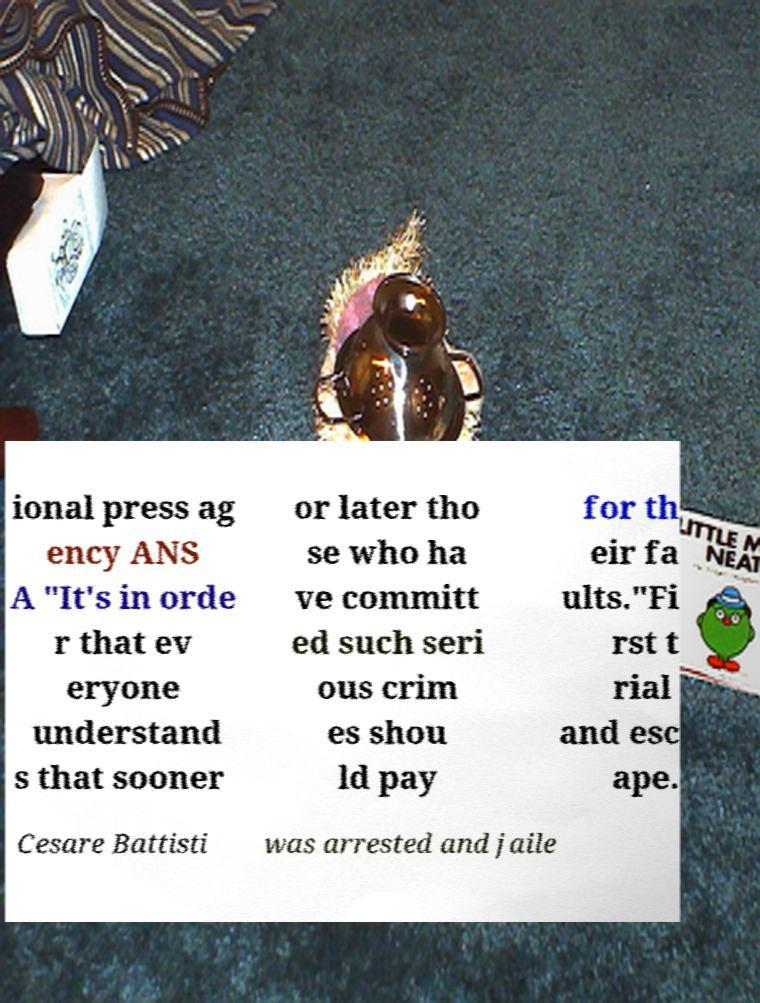I need the written content from this picture converted into text. Can you do that? ional press ag ency ANS A "It's in orde r that ev eryone understand s that sooner or later tho se who ha ve committ ed such seri ous crim es shou ld pay for th eir fa ults."Fi rst t rial and esc ape. Cesare Battisti was arrested and jaile 